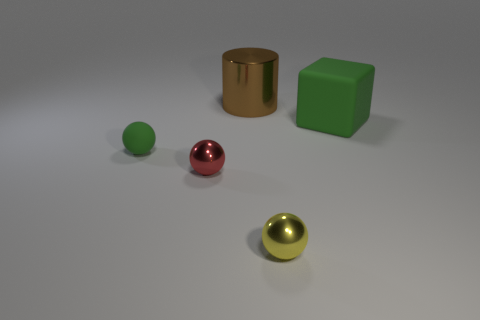Add 5 big brown metal things. How many objects exist? 10 Subtract all spheres. How many objects are left? 2 Add 2 tiny red spheres. How many tiny red spheres are left? 3 Add 2 big gray matte objects. How many big gray matte objects exist? 2 Subtract 0 cyan spheres. How many objects are left? 5 Subtract all small yellow metal cylinders. Subtract all rubber objects. How many objects are left? 3 